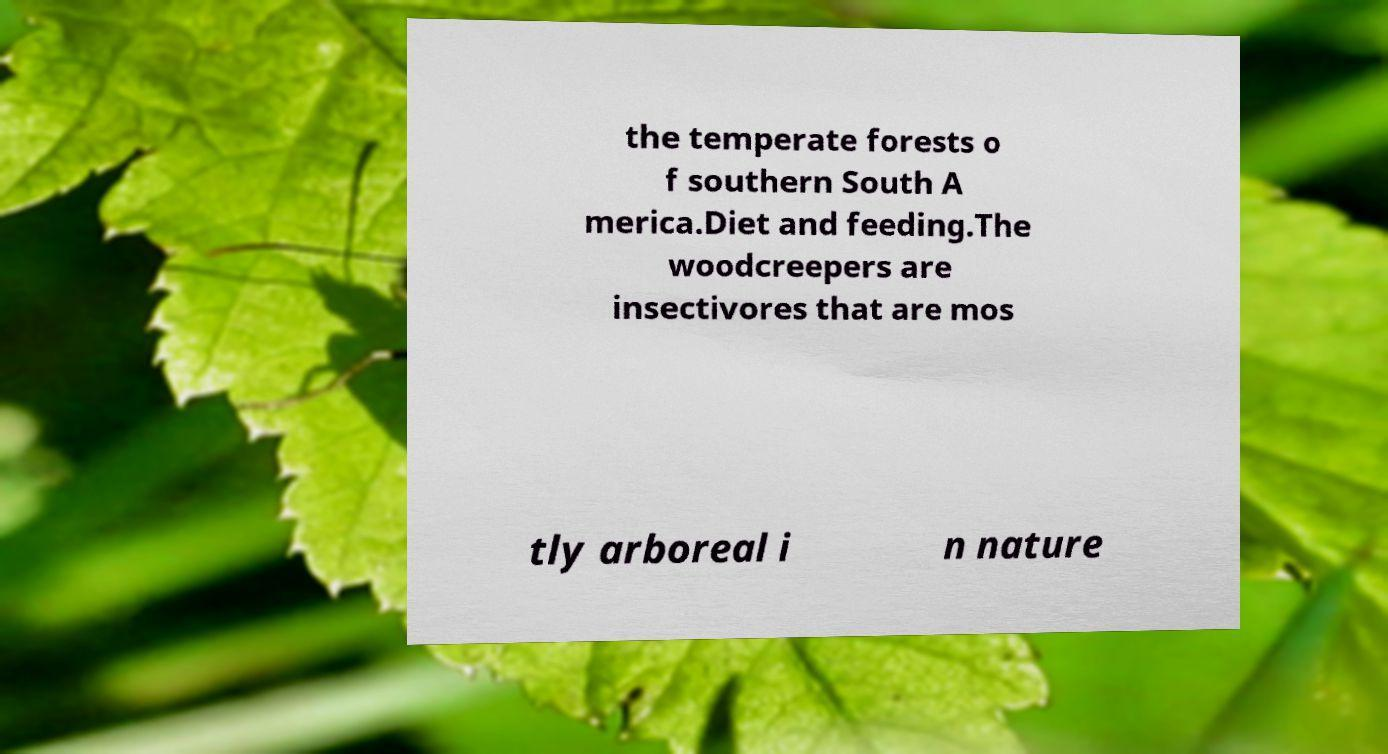Could you assist in decoding the text presented in this image and type it out clearly? the temperate forests o f southern South A merica.Diet and feeding.The woodcreepers are insectivores that are mos tly arboreal i n nature 